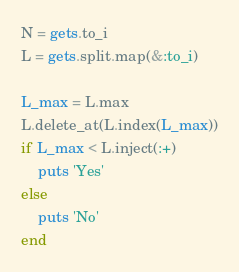Convert code to text. <code><loc_0><loc_0><loc_500><loc_500><_Ruby_>N = gets.to_i
L = gets.split.map(&:to_i)

L_max = L.max
L.delete_at(L.index(L_max))
if L_max < L.inject(:+)
    puts 'Yes'
else
    puts 'No'
end
</code> 